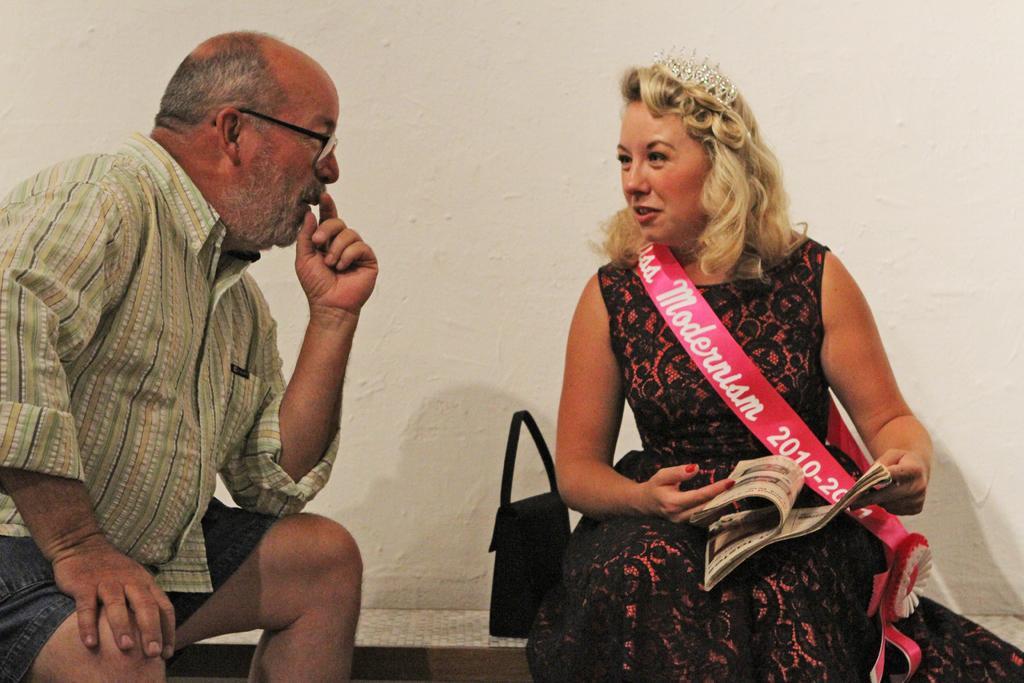Describe this image in one or two sentences. In the foreground of this image, on the left, there is a man sitting. On the right, there is woman sitting wearing a shashe holding a book and we can also see the crown on her head and there is a bag beside her. In the background, there is a white wall. 